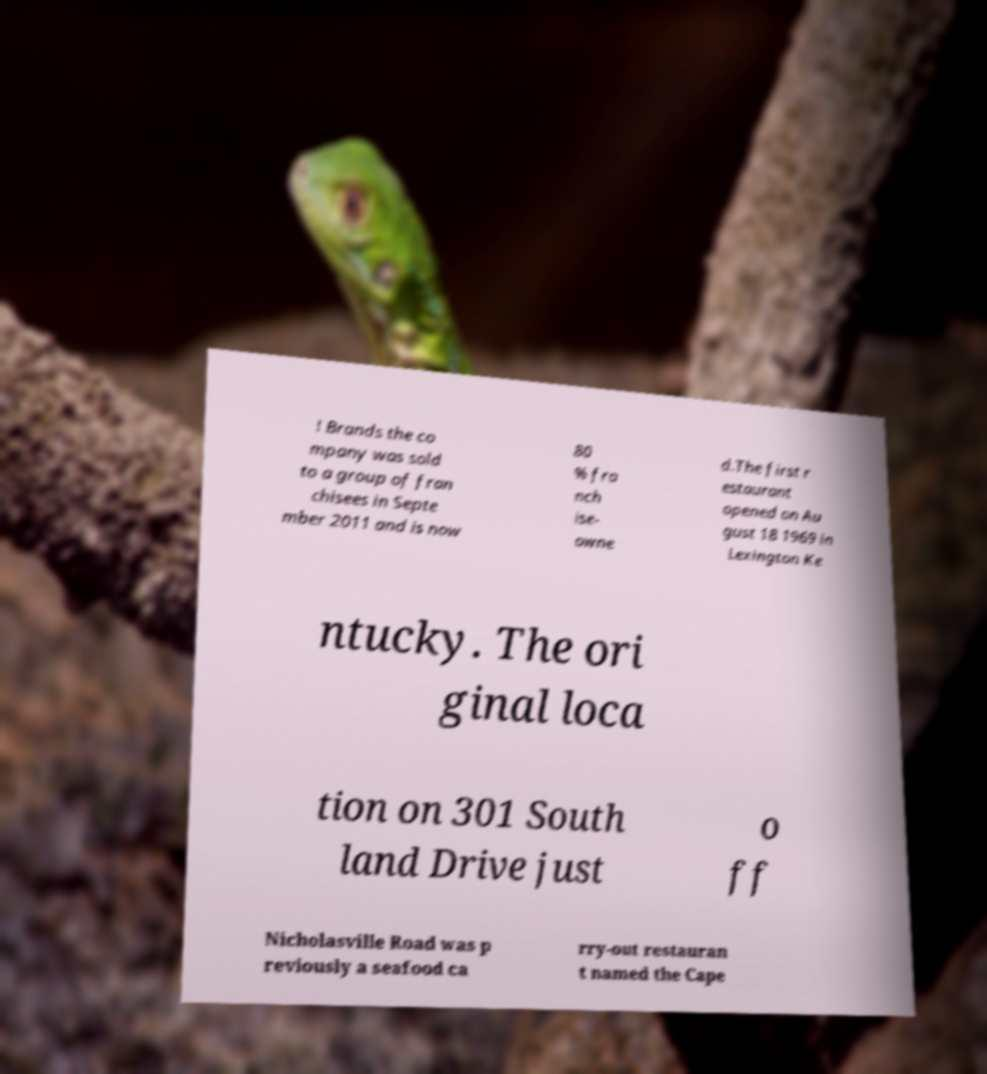There's text embedded in this image that I need extracted. Can you transcribe it verbatim? ! Brands the co mpany was sold to a group of fran chisees in Septe mber 2011 and is now 80 % fra nch ise- owne d.The first r estaurant opened on Au gust 18 1969 in Lexington Ke ntucky. The ori ginal loca tion on 301 South land Drive just o ff Nicholasville Road was p reviously a seafood ca rry-out restauran t named the Cape 